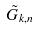<formula> <loc_0><loc_0><loc_500><loc_500>\tilde { G } _ { k , n }</formula> 